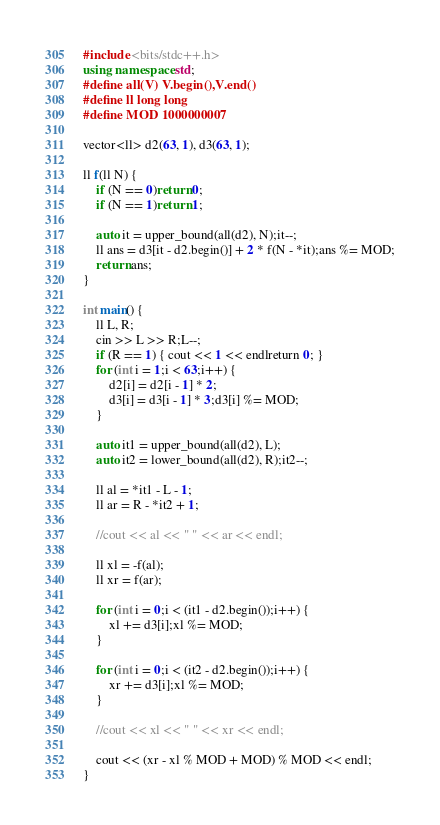<code> <loc_0><loc_0><loc_500><loc_500><_C++_>#include <bits/stdc++.h>
using namespace std;
#define all(V) V.begin(),V.end()
#define ll long long
#define MOD 1000000007

vector<ll> d2(63, 1), d3(63, 1);

ll f(ll N) {
	if (N == 0)return 0;
	if (N == 1)return 1;

	auto it = upper_bound(all(d2), N);it--;
	ll ans = d3[it - d2.begin()] + 2 * f(N - *it);ans %= MOD;
	return ans;
}

int main() {
	ll L, R;
	cin >> L >> R;L--;
	if (R == 1) { cout << 1 << endlreturn 0; }
	for (int i = 1;i < 63;i++) {
		d2[i] = d2[i - 1] * 2;
		d3[i] = d3[i - 1] * 3;d3[i] %= MOD;
	}

	auto it1 = upper_bound(all(d2), L);
	auto it2 = lower_bound(all(d2), R);it2--;

	ll al = *it1 - L - 1;
	ll ar = R - *it2 + 1;

	//cout << al << " " << ar << endl;

	ll xl = -f(al);
	ll xr = f(ar);

	for (int i = 0;i < (it1 - d2.begin());i++) {
		xl += d3[i];xl %= MOD;
	}

	for (int i = 0;i < (it2 - d2.begin());i++) {
		xr += d3[i];xl %= MOD;
	}

	//cout << xl << " " << xr << endl;

	cout << (xr - xl % MOD + MOD) % MOD << endl;
}</code> 